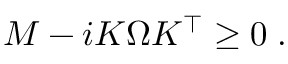<formula> <loc_0><loc_0><loc_500><loc_500>\begin{array} { r } { M - i K \Omega K ^ { \intercal } \geq 0 \, . } \end{array}</formula> 